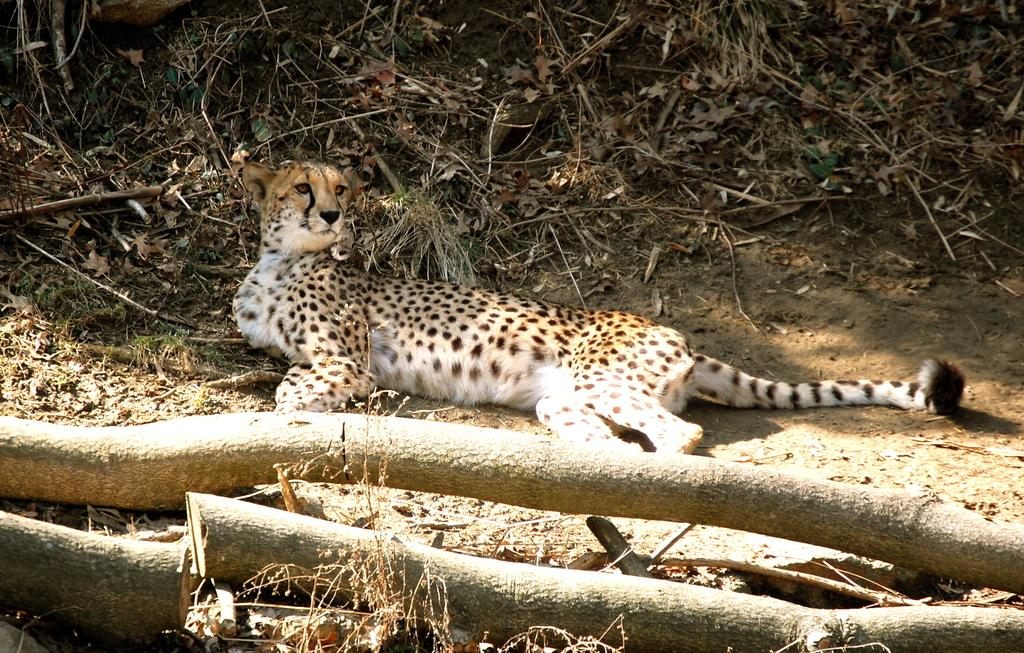What animal is present in the image? There is a cheetah in the image. What is the cheetah doing in the image? The cheetah is laying on the ground. What type of vegetation can be seen in the image? There are dry leaves and dry grass in the image. What objects are present in the image? There are wooden logs in the image. How is the sunlight affecting the wooden logs in the image? A large amount of sunlight is falling on the wooden logs. What type of game is the cheetah playing with the wooden logs in the image? There is no game being played in the image; the cheetah is simply laying on the ground, and the wooden logs are not involved in any activity. 